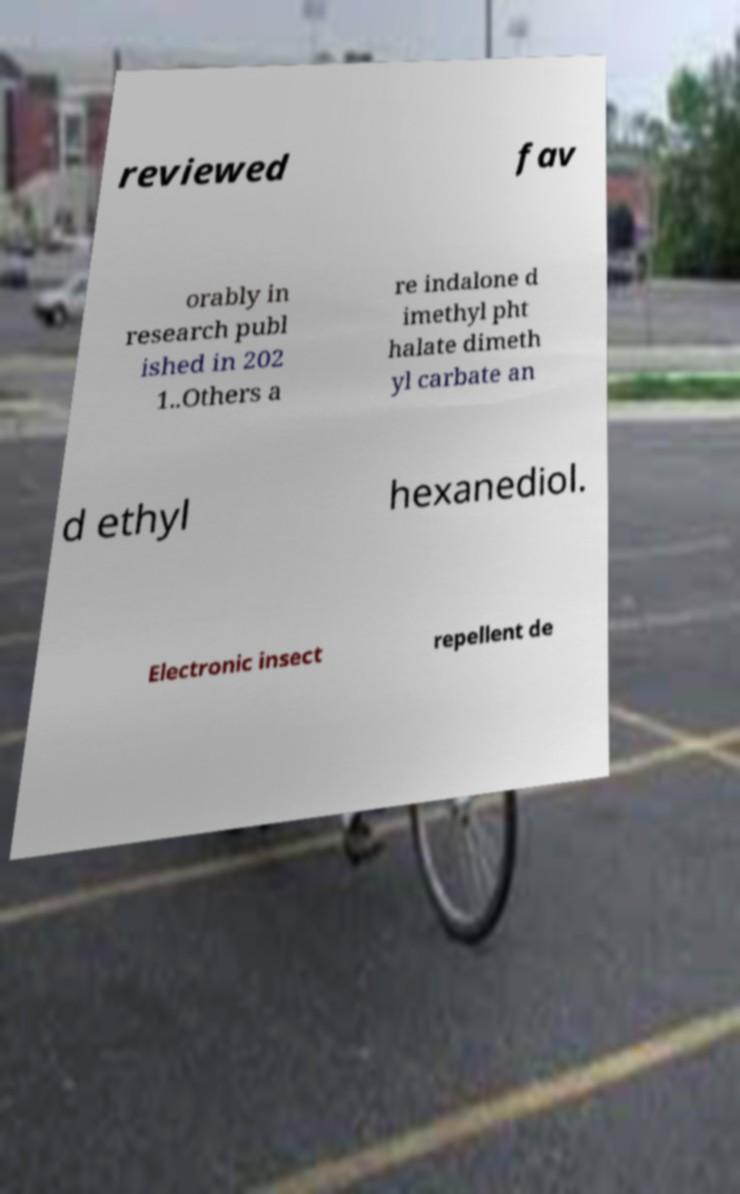I need the written content from this picture converted into text. Can you do that? reviewed fav orably in research publ ished in 202 1..Others a re indalone d imethyl pht halate dimeth yl carbate an d ethyl hexanediol. Electronic insect repellent de 